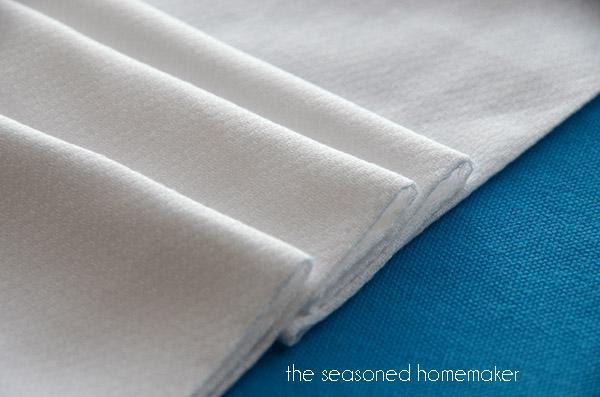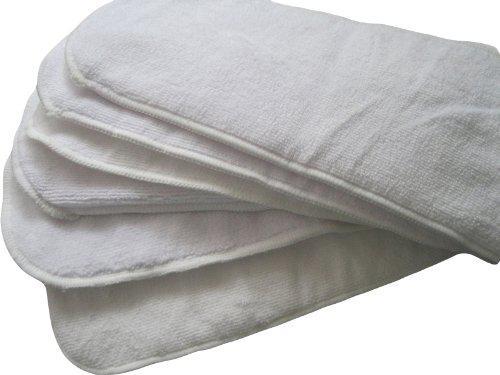The first image is the image on the left, the second image is the image on the right. For the images shown, is this caption "There is toilet paper with a little bit unrolled underneath on the ground." true? Answer yes or no. No. 